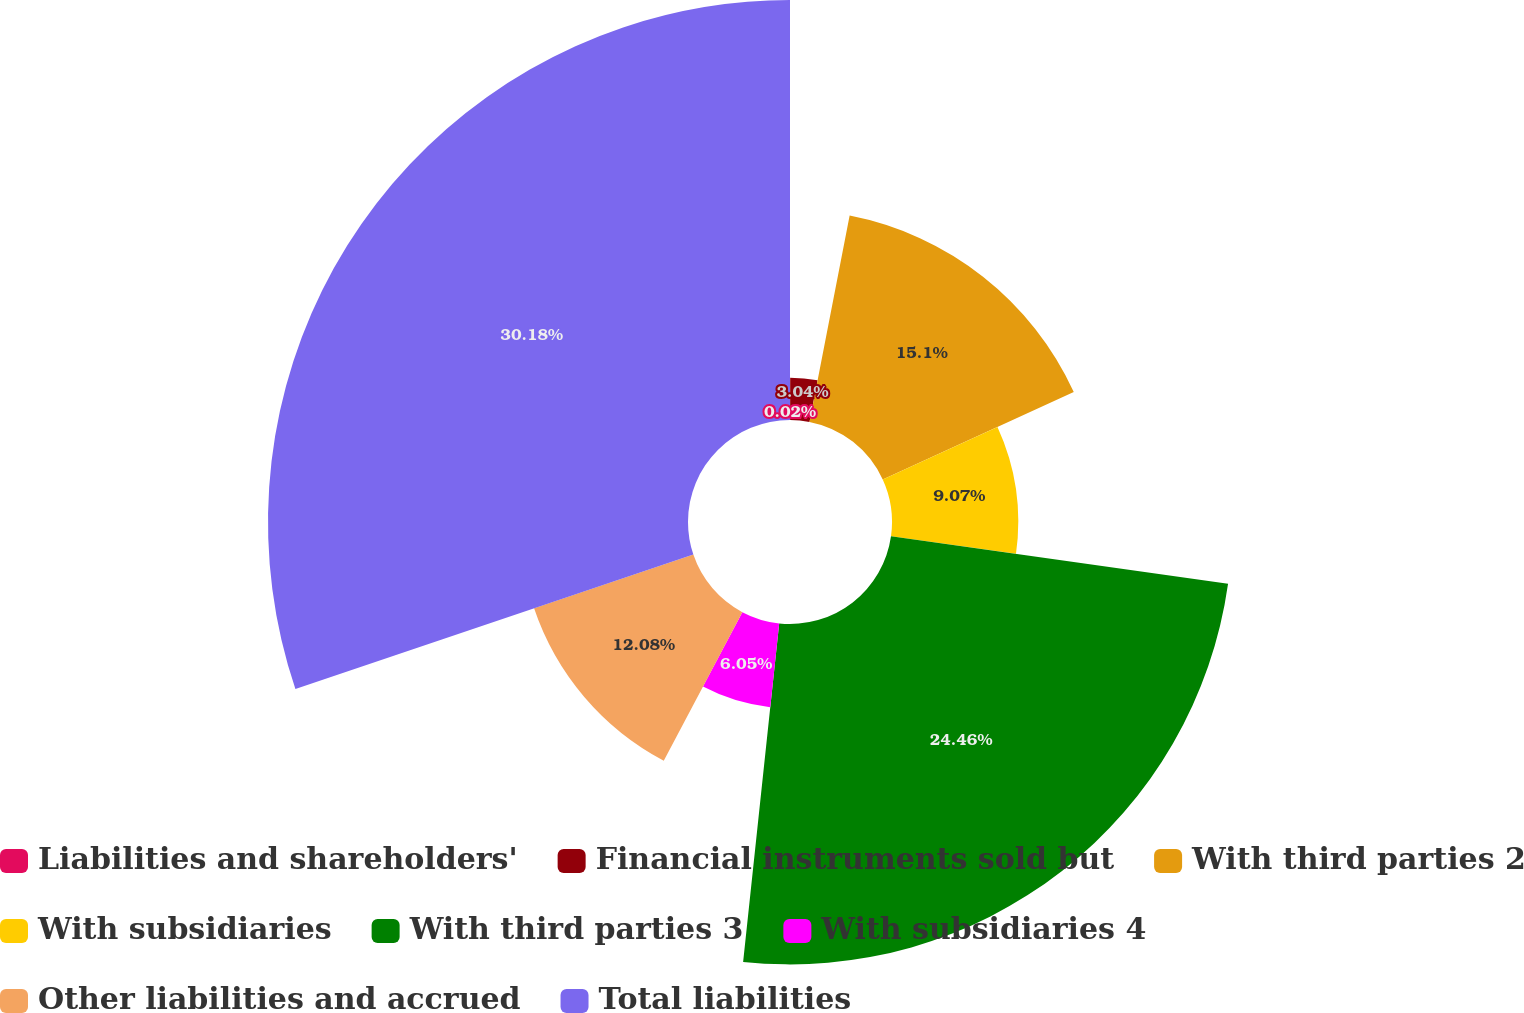Convert chart to OTSL. <chart><loc_0><loc_0><loc_500><loc_500><pie_chart><fcel>Liabilities and shareholders'<fcel>Financial instruments sold but<fcel>With third parties 2<fcel>With subsidiaries<fcel>With third parties 3<fcel>With subsidiaries 4<fcel>Other liabilities and accrued<fcel>Total liabilities<nl><fcel>0.02%<fcel>3.04%<fcel>15.1%<fcel>9.07%<fcel>24.46%<fcel>6.05%<fcel>12.08%<fcel>30.18%<nl></chart> 